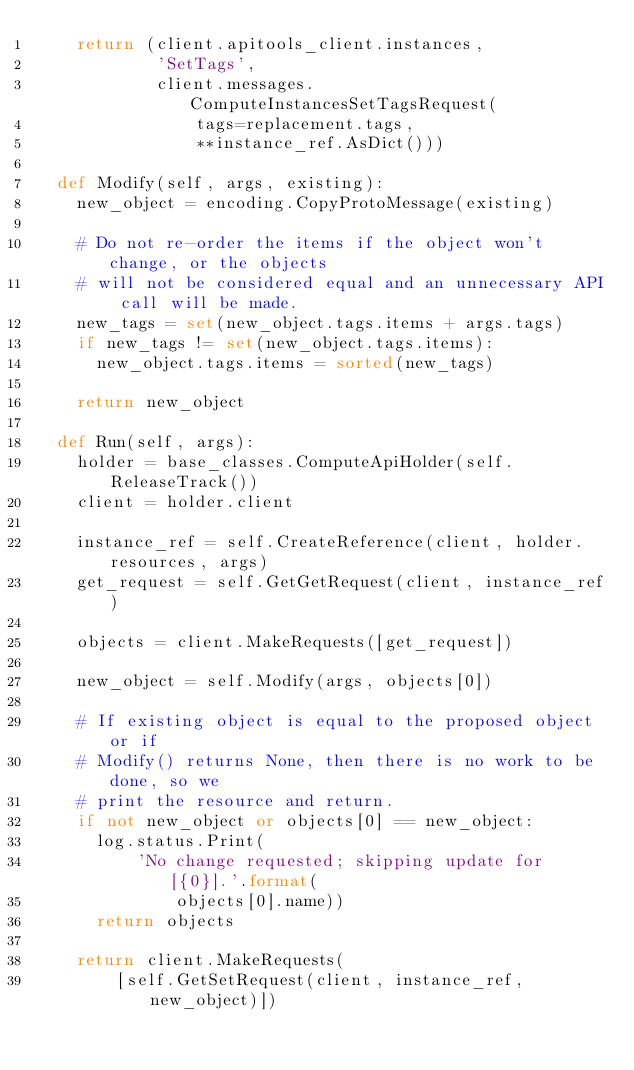Convert code to text. <code><loc_0><loc_0><loc_500><loc_500><_Python_>    return (client.apitools_client.instances,
            'SetTags',
            client.messages.ComputeInstancesSetTagsRequest(
                tags=replacement.tags,
                **instance_ref.AsDict()))

  def Modify(self, args, existing):
    new_object = encoding.CopyProtoMessage(existing)

    # Do not re-order the items if the object won't change, or the objects
    # will not be considered equal and an unnecessary API call will be made.
    new_tags = set(new_object.tags.items + args.tags)
    if new_tags != set(new_object.tags.items):
      new_object.tags.items = sorted(new_tags)

    return new_object

  def Run(self, args):
    holder = base_classes.ComputeApiHolder(self.ReleaseTrack())
    client = holder.client

    instance_ref = self.CreateReference(client, holder.resources, args)
    get_request = self.GetGetRequest(client, instance_ref)

    objects = client.MakeRequests([get_request])

    new_object = self.Modify(args, objects[0])

    # If existing object is equal to the proposed object or if
    # Modify() returns None, then there is no work to be done, so we
    # print the resource and return.
    if not new_object or objects[0] == new_object:
      log.status.Print(
          'No change requested; skipping update for [{0}].'.format(
              objects[0].name))
      return objects

    return client.MakeRequests(
        [self.GetSetRequest(client, instance_ref, new_object)])
</code> 